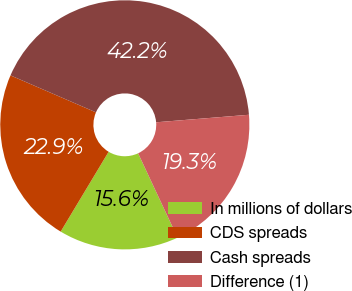Convert chart. <chart><loc_0><loc_0><loc_500><loc_500><pie_chart><fcel>In millions of dollars<fcel>CDS spreads<fcel>Cash spreads<fcel>Difference (1)<nl><fcel>15.57%<fcel>22.89%<fcel>42.22%<fcel>19.33%<nl></chart> 